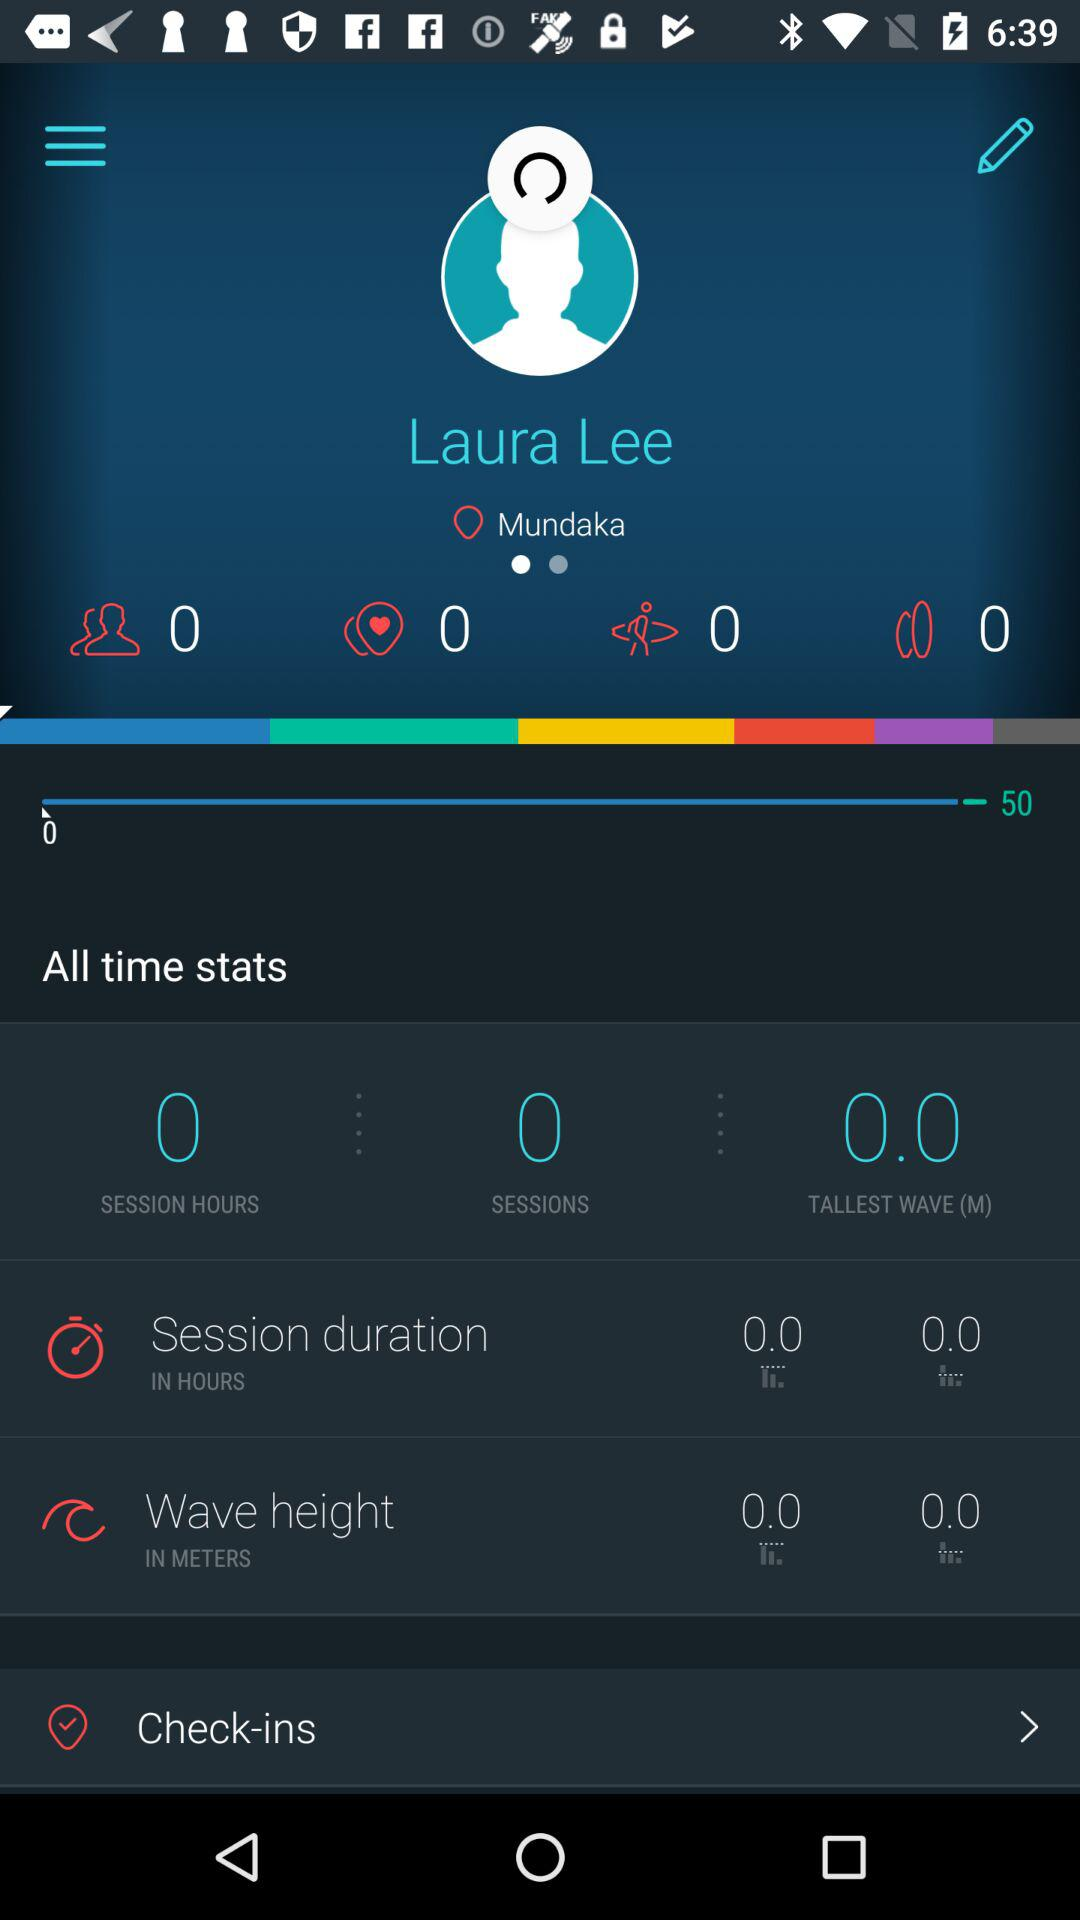How many sessions are there? There are 0 sessions. 